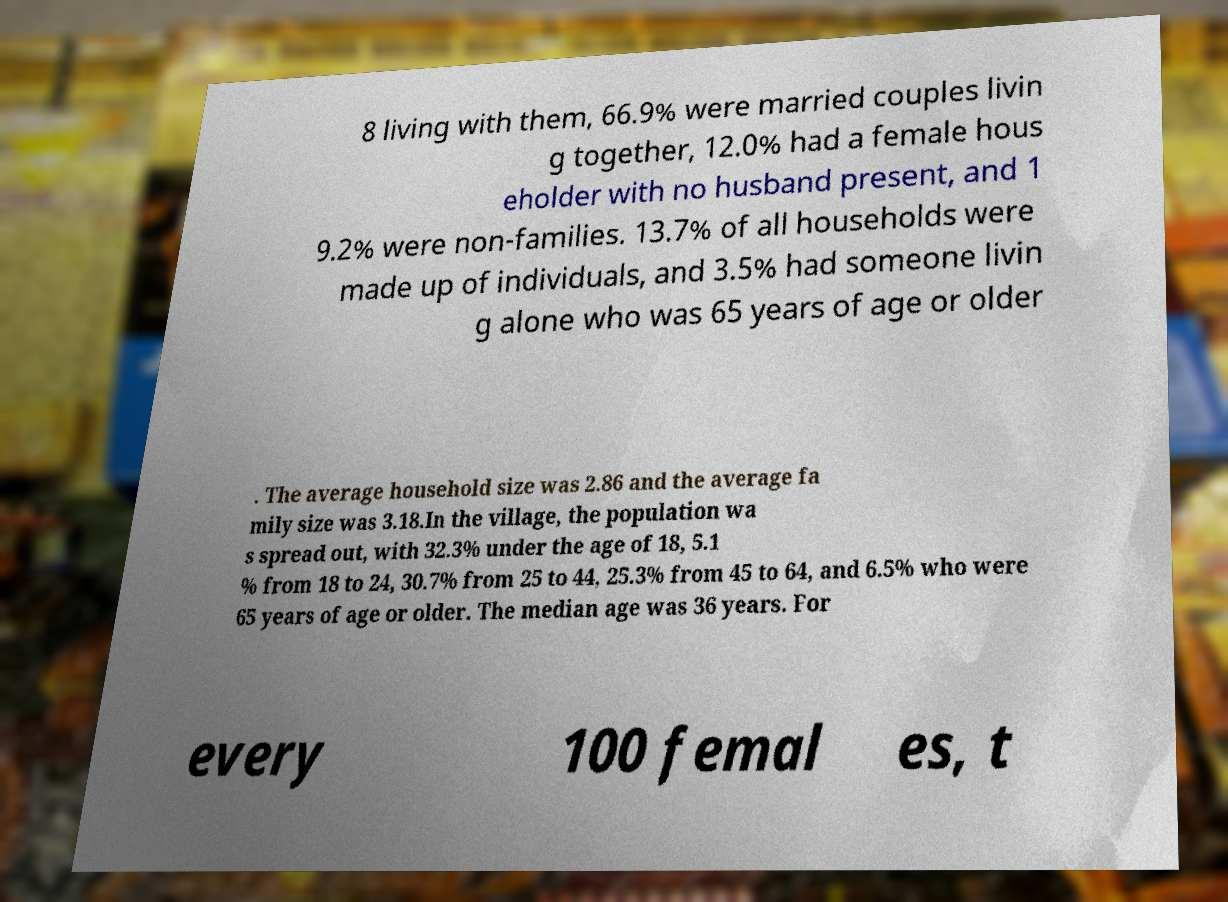What messages or text are displayed in this image? I need them in a readable, typed format. 8 living with them, 66.9% were married couples livin g together, 12.0% had a female hous eholder with no husband present, and 1 9.2% were non-families. 13.7% of all households were made up of individuals, and 3.5% had someone livin g alone who was 65 years of age or older . The average household size was 2.86 and the average fa mily size was 3.18.In the village, the population wa s spread out, with 32.3% under the age of 18, 5.1 % from 18 to 24, 30.7% from 25 to 44, 25.3% from 45 to 64, and 6.5% who were 65 years of age or older. The median age was 36 years. For every 100 femal es, t 